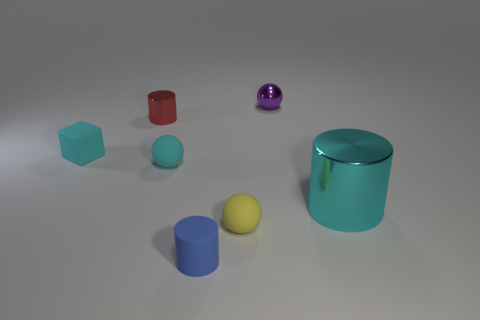Subtract all cylinders. How many objects are left? 4 Add 1 gray shiny spheres. How many objects exist? 8 Subtract all tiny purple spheres. Subtract all purple objects. How many objects are left? 5 Add 1 red shiny objects. How many red shiny objects are left? 2 Add 7 small cyan rubber blocks. How many small cyan rubber blocks exist? 8 Subtract 0 gray blocks. How many objects are left? 7 